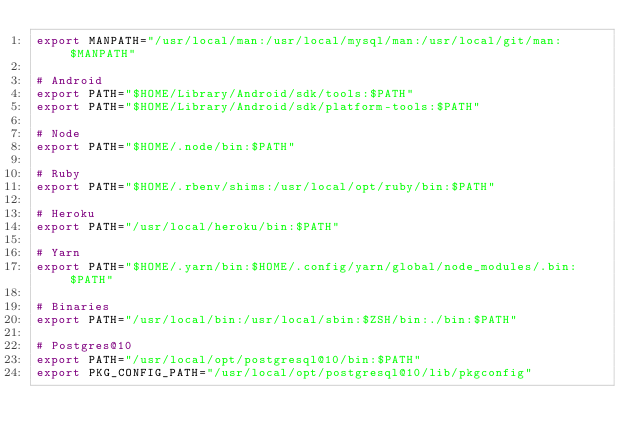<code> <loc_0><loc_0><loc_500><loc_500><_Bash_>export MANPATH="/usr/local/man:/usr/local/mysql/man:/usr/local/git/man:$MANPATH"

# Android
export PATH="$HOME/Library/Android/sdk/tools:$PATH"
export PATH="$HOME/Library/Android/sdk/platform-tools:$PATH"

# Node
export PATH="$HOME/.node/bin:$PATH"

# Ruby
export PATH="$HOME/.rbenv/shims:/usr/local/opt/ruby/bin:$PATH"

# Heroku
export PATH="/usr/local/heroku/bin:$PATH"

# Yarn
export PATH="$HOME/.yarn/bin:$HOME/.config/yarn/global/node_modules/.bin:$PATH"

# Binaries
export PATH="/usr/local/bin:/usr/local/sbin:$ZSH/bin:./bin:$PATH"

# Postgres@10
export PATH="/usr/local/opt/postgresql@10/bin:$PATH"
export PKG_CONFIG_PATH="/usr/local/opt/postgresql@10/lib/pkgconfig"
</code> 